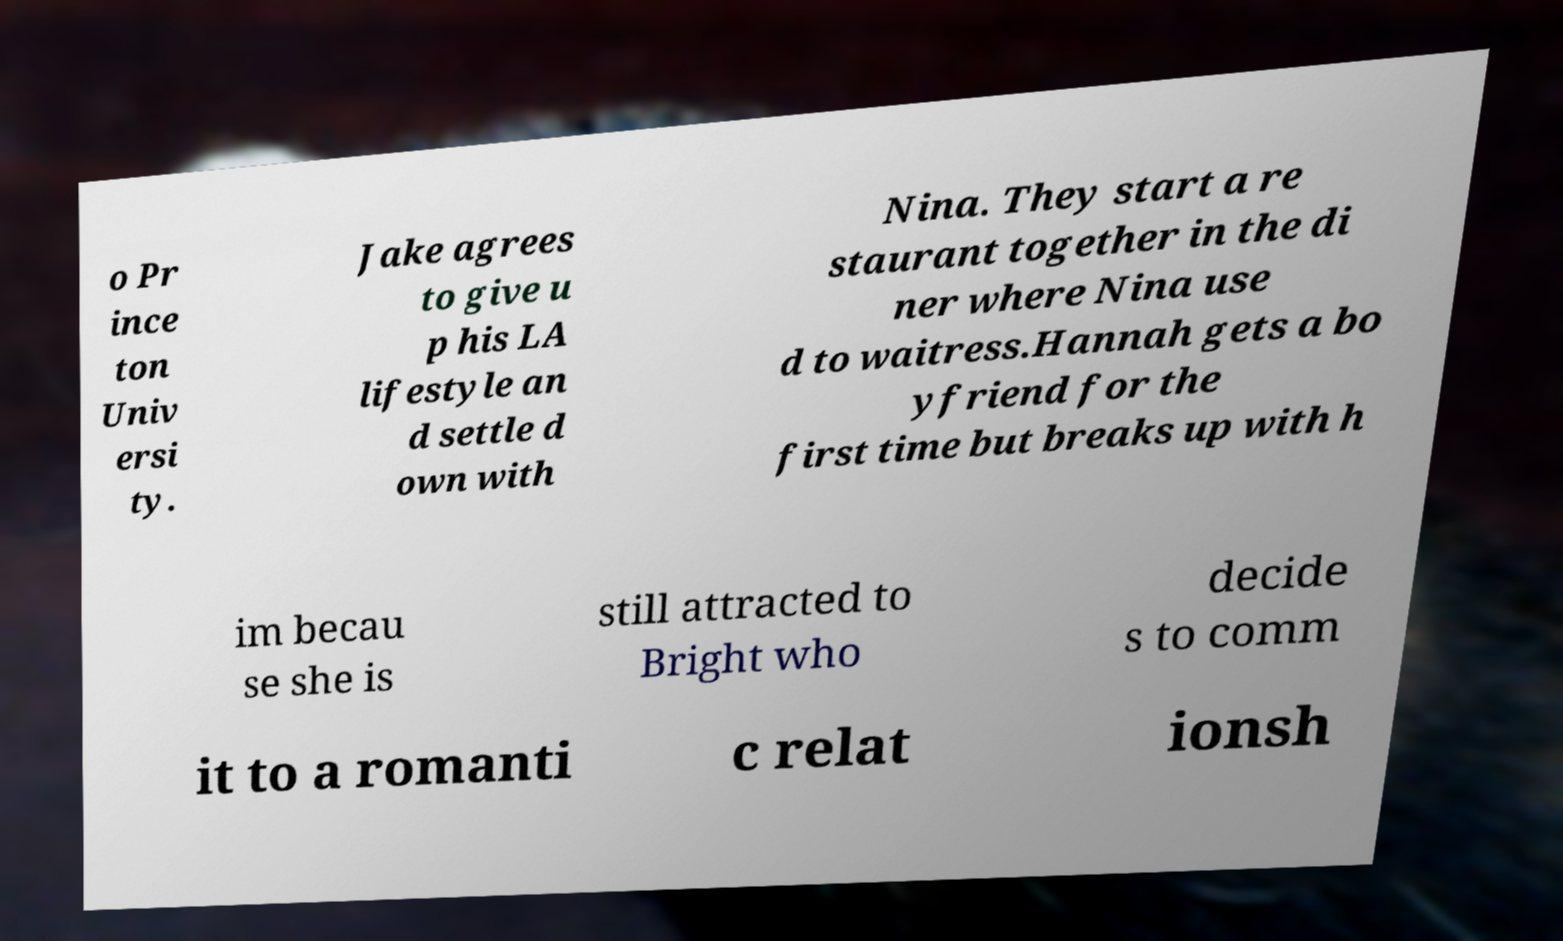Could you assist in decoding the text presented in this image and type it out clearly? o Pr ince ton Univ ersi ty. Jake agrees to give u p his LA lifestyle an d settle d own with Nina. They start a re staurant together in the di ner where Nina use d to waitress.Hannah gets a bo yfriend for the first time but breaks up with h im becau se she is still attracted to Bright who decide s to comm it to a romanti c relat ionsh 